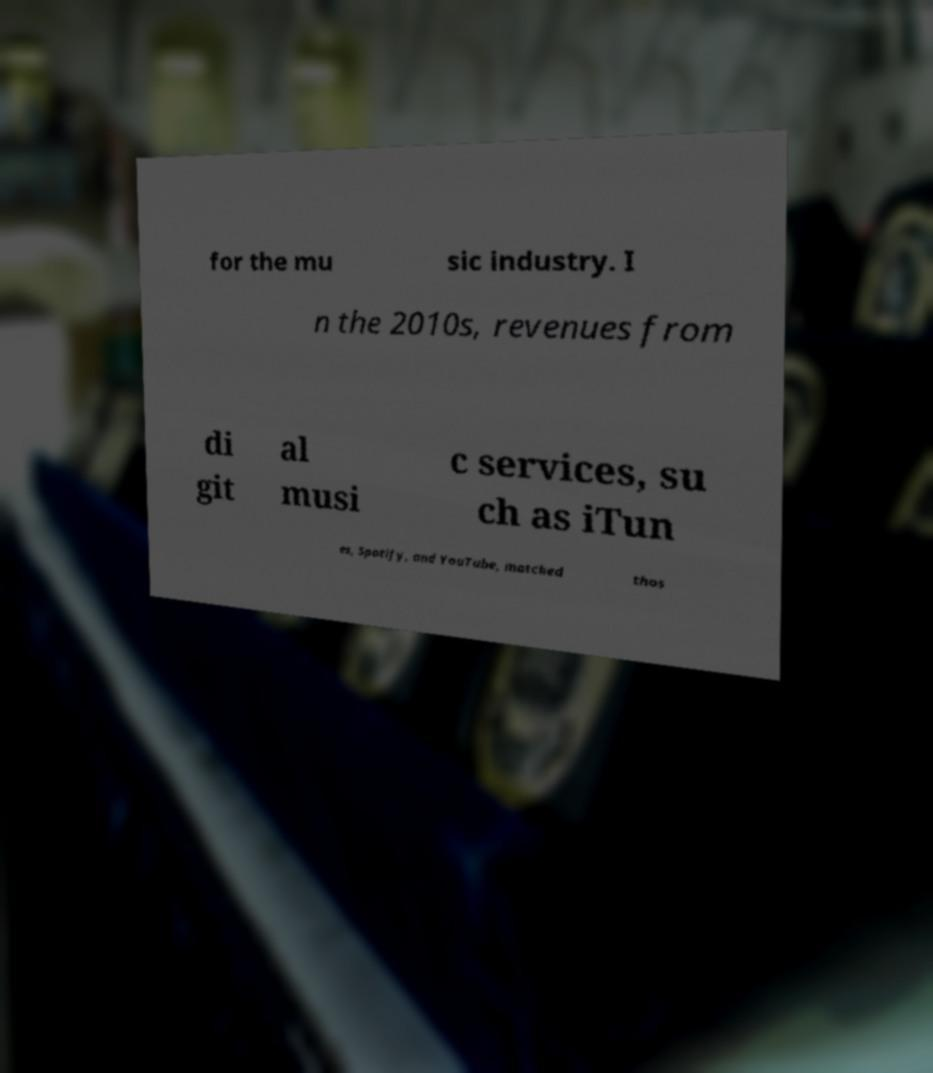What messages or text are displayed in this image? I need them in a readable, typed format. for the mu sic industry. I n the 2010s, revenues from di git al musi c services, su ch as iTun es, Spotify, and YouTube, matched thos 